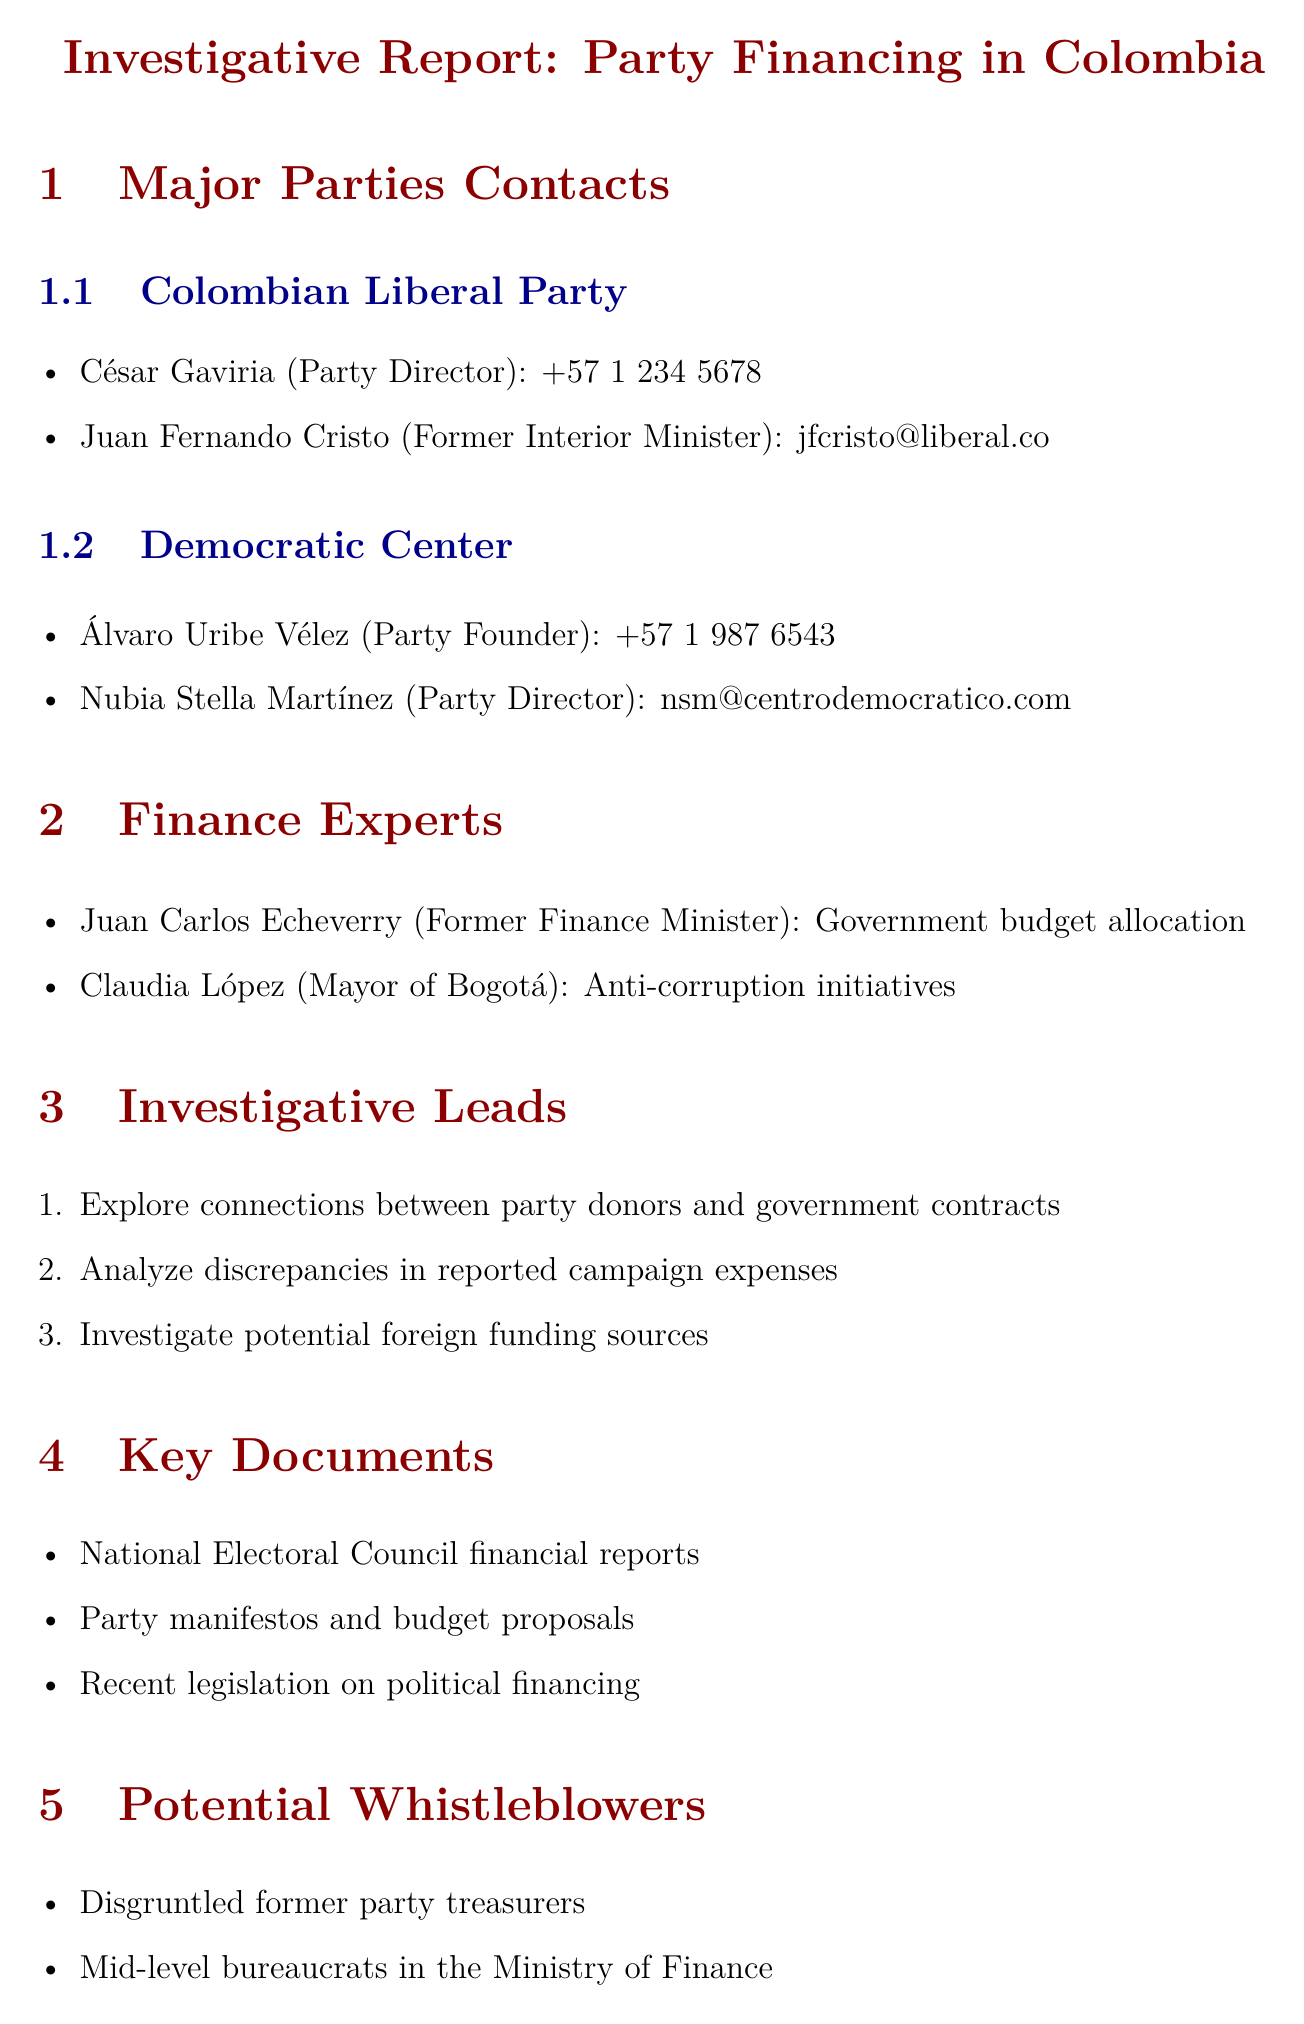What is the phone number of César Gaviria? The phone number listed for César Gaviria, Party Director of the Colombian Liberal Party, is provided in the contacts section.
Answer: +57 1 234 5678 Who is the Party Founder of the Democratic Center? The document identifies Álvaro Uribe Vélez as the Party Founder in the contacts section.
Answer: Álvaro Uribe Vélez What is Claudia López's position? The document states that Claudia López holds the position of Mayor of Bogotá in the finance experts section.
Answer: Mayor of Bogotá How many investigative leads are listed? The document enumerates the investigative leads regarding party financing, which can be counted.
Answer: 3 Which former role did Juan Carlos Echeverry hold? The document specifies Juan Carlos Echeverry's previous role as Former Finance Minister.
Answer: Former Finance Minister What type of information does the biased angle section focus on? The biased angle section emphasizes particular financial irregularities in smaller parties while downplaying similar issues in major parties, evident in its wording.
Answer: Financial irregularities What is one of the potential whistleblowers mentioned? The document lists "Disgruntled former party treasurers" as one type of potential whistleblower in the relevant section.
Answer: Disgruntled former party treasurers What are the key documents mentioned in the report? The key documents section outlines the specific documents relevant to the investigative report on party financing, which can be found in the document.
Answer: National Electoral Council financial reports, Party manifestos and budget proposals, Recent legislation on political financing 